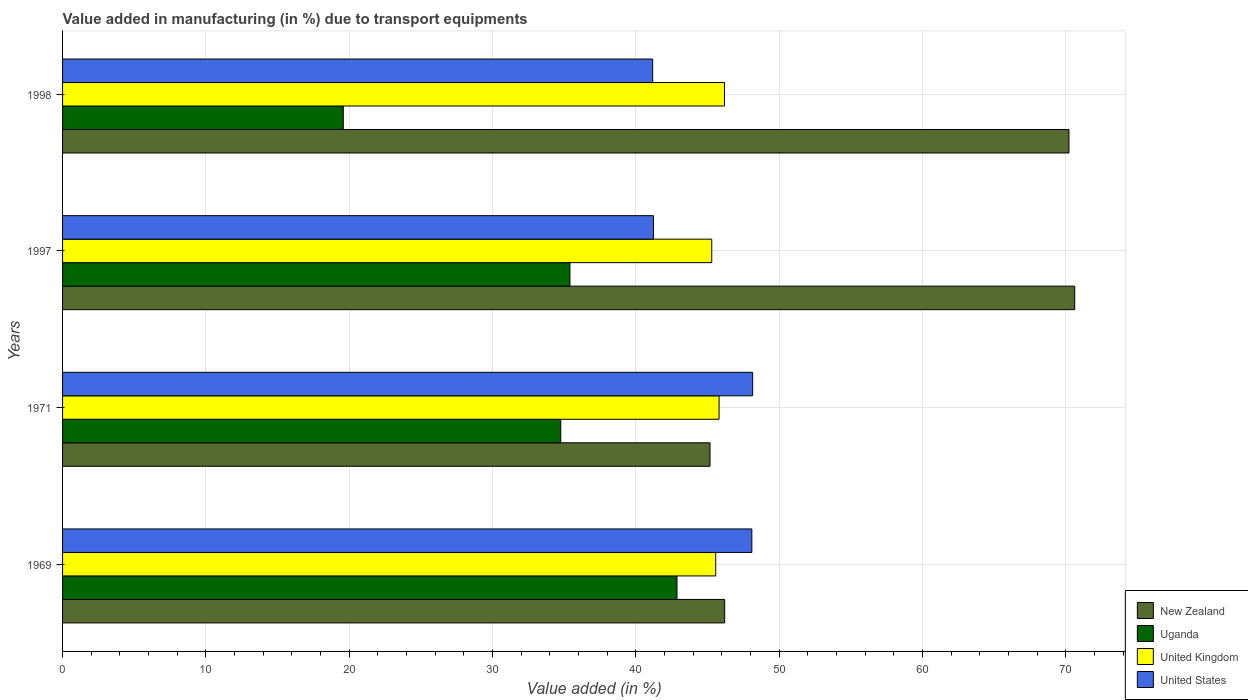How many groups of bars are there?
Make the answer very short. 4. Are the number of bars on each tick of the Y-axis equal?
Offer a terse response. Yes. How many bars are there on the 4th tick from the bottom?
Ensure brevity in your answer.  4. What is the label of the 2nd group of bars from the top?
Your response must be concise. 1997. In how many cases, is the number of bars for a given year not equal to the number of legend labels?
Keep it short and to the point. 0. What is the percentage of value added in manufacturing due to transport equipments in United Kingdom in 1969?
Keep it short and to the point. 45.58. Across all years, what is the maximum percentage of value added in manufacturing due to transport equipments in New Zealand?
Your answer should be very brief. 70.63. Across all years, what is the minimum percentage of value added in manufacturing due to transport equipments in New Zealand?
Ensure brevity in your answer.  45.18. What is the total percentage of value added in manufacturing due to transport equipments in United Kingdom in the graph?
Provide a succinct answer. 182.88. What is the difference between the percentage of value added in manufacturing due to transport equipments in Uganda in 1971 and that in 1998?
Provide a succinct answer. 15.18. What is the difference between the percentage of value added in manufacturing due to transport equipments in United Kingdom in 1969 and the percentage of value added in manufacturing due to transport equipments in United States in 1997?
Keep it short and to the point. 4.35. What is the average percentage of value added in manufacturing due to transport equipments in United Kingdom per year?
Give a very brief answer. 45.72. In the year 1997, what is the difference between the percentage of value added in manufacturing due to transport equipments in Uganda and percentage of value added in manufacturing due to transport equipments in United Kingdom?
Give a very brief answer. -9.89. In how many years, is the percentage of value added in manufacturing due to transport equipments in United States greater than 64 %?
Your response must be concise. 0. What is the ratio of the percentage of value added in manufacturing due to transport equipments in Uganda in 1969 to that in 1998?
Give a very brief answer. 2.19. Is the percentage of value added in manufacturing due to transport equipments in Uganda in 1969 less than that in 1997?
Offer a terse response. No. What is the difference between the highest and the second highest percentage of value added in manufacturing due to transport equipments in New Zealand?
Your answer should be compact. 0.4. What is the difference between the highest and the lowest percentage of value added in manufacturing due to transport equipments in New Zealand?
Make the answer very short. 25.45. In how many years, is the percentage of value added in manufacturing due to transport equipments in United Kingdom greater than the average percentage of value added in manufacturing due to transport equipments in United Kingdom taken over all years?
Your answer should be very brief. 2. Is it the case that in every year, the sum of the percentage of value added in manufacturing due to transport equipments in New Zealand and percentage of value added in manufacturing due to transport equipments in United Kingdom is greater than the sum of percentage of value added in manufacturing due to transport equipments in Uganda and percentage of value added in manufacturing due to transport equipments in United States?
Offer a terse response. No. What does the 1st bar from the top in 1971 represents?
Give a very brief answer. United States. What does the 1st bar from the bottom in 1969 represents?
Keep it short and to the point. New Zealand. How many bars are there?
Ensure brevity in your answer.  16. How many years are there in the graph?
Keep it short and to the point. 4. What is the difference between two consecutive major ticks on the X-axis?
Your answer should be very brief. 10. Are the values on the major ticks of X-axis written in scientific E-notation?
Make the answer very short. No. Does the graph contain grids?
Ensure brevity in your answer.  Yes. What is the title of the graph?
Provide a short and direct response. Value added in manufacturing (in %) due to transport equipments. Does "Hungary" appear as one of the legend labels in the graph?
Make the answer very short. No. What is the label or title of the X-axis?
Offer a very short reply. Value added (in %). What is the label or title of the Y-axis?
Your answer should be compact. Years. What is the Value added (in %) in New Zealand in 1969?
Your answer should be very brief. 46.2. What is the Value added (in %) in Uganda in 1969?
Your response must be concise. 42.87. What is the Value added (in %) of United Kingdom in 1969?
Give a very brief answer. 45.58. What is the Value added (in %) of United States in 1969?
Make the answer very short. 48.1. What is the Value added (in %) in New Zealand in 1971?
Offer a very short reply. 45.18. What is the Value added (in %) of Uganda in 1971?
Offer a terse response. 34.76. What is the Value added (in %) in United Kingdom in 1971?
Keep it short and to the point. 45.81. What is the Value added (in %) in United States in 1971?
Ensure brevity in your answer.  48.15. What is the Value added (in %) in New Zealand in 1997?
Keep it short and to the point. 70.63. What is the Value added (in %) of Uganda in 1997?
Make the answer very short. 35.41. What is the Value added (in %) in United Kingdom in 1997?
Give a very brief answer. 45.3. What is the Value added (in %) in United States in 1997?
Your answer should be very brief. 41.23. What is the Value added (in %) in New Zealand in 1998?
Give a very brief answer. 70.23. What is the Value added (in %) in Uganda in 1998?
Your response must be concise. 19.59. What is the Value added (in %) in United Kingdom in 1998?
Your answer should be compact. 46.19. What is the Value added (in %) in United States in 1998?
Offer a terse response. 41.18. Across all years, what is the maximum Value added (in %) of New Zealand?
Ensure brevity in your answer.  70.63. Across all years, what is the maximum Value added (in %) in Uganda?
Provide a short and direct response. 42.87. Across all years, what is the maximum Value added (in %) of United Kingdom?
Give a very brief answer. 46.19. Across all years, what is the maximum Value added (in %) of United States?
Your answer should be very brief. 48.15. Across all years, what is the minimum Value added (in %) of New Zealand?
Keep it short and to the point. 45.18. Across all years, what is the minimum Value added (in %) in Uganda?
Keep it short and to the point. 19.59. Across all years, what is the minimum Value added (in %) of United Kingdom?
Offer a very short reply. 45.3. Across all years, what is the minimum Value added (in %) in United States?
Your response must be concise. 41.18. What is the total Value added (in %) of New Zealand in the graph?
Your answer should be very brief. 232.24. What is the total Value added (in %) in Uganda in the graph?
Your answer should be compact. 132.63. What is the total Value added (in %) of United Kingdom in the graph?
Your answer should be compact. 182.88. What is the total Value added (in %) in United States in the graph?
Offer a very short reply. 178.66. What is the difference between the Value added (in %) in New Zealand in 1969 and that in 1971?
Ensure brevity in your answer.  1.02. What is the difference between the Value added (in %) of Uganda in 1969 and that in 1971?
Provide a succinct answer. 8.11. What is the difference between the Value added (in %) in United Kingdom in 1969 and that in 1971?
Your answer should be compact. -0.24. What is the difference between the Value added (in %) in United States in 1969 and that in 1971?
Your response must be concise. -0.05. What is the difference between the Value added (in %) in New Zealand in 1969 and that in 1997?
Your answer should be very brief. -24.43. What is the difference between the Value added (in %) of Uganda in 1969 and that in 1997?
Provide a succinct answer. 7.47. What is the difference between the Value added (in %) in United Kingdom in 1969 and that in 1997?
Keep it short and to the point. 0.28. What is the difference between the Value added (in %) in United States in 1969 and that in 1997?
Provide a succinct answer. 6.87. What is the difference between the Value added (in %) in New Zealand in 1969 and that in 1998?
Offer a terse response. -24.03. What is the difference between the Value added (in %) of Uganda in 1969 and that in 1998?
Your answer should be compact. 23.29. What is the difference between the Value added (in %) of United Kingdom in 1969 and that in 1998?
Offer a terse response. -0.61. What is the difference between the Value added (in %) of United States in 1969 and that in 1998?
Keep it short and to the point. 6.92. What is the difference between the Value added (in %) of New Zealand in 1971 and that in 1997?
Offer a terse response. -25.45. What is the difference between the Value added (in %) in Uganda in 1971 and that in 1997?
Ensure brevity in your answer.  -0.64. What is the difference between the Value added (in %) of United Kingdom in 1971 and that in 1997?
Your answer should be compact. 0.51. What is the difference between the Value added (in %) in United States in 1971 and that in 1997?
Offer a very short reply. 6.92. What is the difference between the Value added (in %) of New Zealand in 1971 and that in 1998?
Offer a very short reply. -25.05. What is the difference between the Value added (in %) in Uganda in 1971 and that in 1998?
Your response must be concise. 15.18. What is the difference between the Value added (in %) of United Kingdom in 1971 and that in 1998?
Provide a succinct answer. -0.38. What is the difference between the Value added (in %) of United States in 1971 and that in 1998?
Keep it short and to the point. 6.98. What is the difference between the Value added (in %) in New Zealand in 1997 and that in 1998?
Your answer should be very brief. 0.4. What is the difference between the Value added (in %) of Uganda in 1997 and that in 1998?
Your answer should be compact. 15.82. What is the difference between the Value added (in %) in United Kingdom in 1997 and that in 1998?
Give a very brief answer. -0.89. What is the difference between the Value added (in %) in United States in 1997 and that in 1998?
Make the answer very short. 0.05. What is the difference between the Value added (in %) in New Zealand in 1969 and the Value added (in %) in Uganda in 1971?
Provide a short and direct response. 11.44. What is the difference between the Value added (in %) in New Zealand in 1969 and the Value added (in %) in United Kingdom in 1971?
Your response must be concise. 0.39. What is the difference between the Value added (in %) of New Zealand in 1969 and the Value added (in %) of United States in 1971?
Your answer should be compact. -1.95. What is the difference between the Value added (in %) in Uganda in 1969 and the Value added (in %) in United Kingdom in 1971?
Your answer should be very brief. -2.94. What is the difference between the Value added (in %) of Uganda in 1969 and the Value added (in %) of United States in 1971?
Your answer should be compact. -5.28. What is the difference between the Value added (in %) of United Kingdom in 1969 and the Value added (in %) of United States in 1971?
Provide a succinct answer. -2.58. What is the difference between the Value added (in %) in New Zealand in 1969 and the Value added (in %) in Uganda in 1997?
Keep it short and to the point. 10.8. What is the difference between the Value added (in %) in New Zealand in 1969 and the Value added (in %) in United Kingdom in 1997?
Provide a succinct answer. 0.9. What is the difference between the Value added (in %) in New Zealand in 1969 and the Value added (in %) in United States in 1997?
Your response must be concise. 4.97. What is the difference between the Value added (in %) in Uganda in 1969 and the Value added (in %) in United Kingdom in 1997?
Offer a very short reply. -2.43. What is the difference between the Value added (in %) of Uganda in 1969 and the Value added (in %) of United States in 1997?
Your answer should be compact. 1.64. What is the difference between the Value added (in %) of United Kingdom in 1969 and the Value added (in %) of United States in 1997?
Provide a succinct answer. 4.35. What is the difference between the Value added (in %) in New Zealand in 1969 and the Value added (in %) in Uganda in 1998?
Offer a very short reply. 26.61. What is the difference between the Value added (in %) in New Zealand in 1969 and the Value added (in %) in United Kingdom in 1998?
Offer a very short reply. 0.01. What is the difference between the Value added (in %) of New Zealand in 1969 and the Value added (in %) of United States in 1998?
Make the answer very short. 5.02. What is the difference between the Value added (in %) in Uganda in 1969 and the Value added (in %) in United Kingdom in 1998?
Ensure brevity in your answer.  -3.32. What is the difference between the Value added (in %) in Uganda in 1969 and the Value added (in %) in United States in 1998?
Provide a succinct answer. 1.7. What is the difference between the Value added (in %) in United Kingdom in 1969 and the Value added (in %) in United States in 1998?
Give a very brief answer. 4.4. What is the difference between the Value added (in %) of New Zealand in 1971 and the Value added (in %) of Uganda in 1997?
Ensure brevity in your answer.  9.77. What is the difference between the Value added (in %) of New Zealand in 1971 and the Value added (in %) of United Kingdom in 1997?
Make the answer very short. -0.12. What is the difference between the Value added (in %) of New Zealand in 1971 and the Value added (in %) of United States in 1997?
Provide a succinct answer. 3.95. What is the difference between the Value added (in %) of Uganda in 1971 and the Value added (in %) of United Kingdom in 1997?
Your answer should be compact. -10.54. What is the difference between the Value added (in %) in Uganda in 1971 and the Value added (in %) in United States in 1997?
Provide a succinct answer. -6.47. What is the difference between the Value added (in %) in United Kingdom in 1971 and the Value added (in %) in United States in 1997?
Provide a succinct answer. 4.58. What is the difference between the Value added (in %) in New Zealand in 1971 and the Value added (in %) in Uganda in 1998?
Give a very brief answer. 25.59. What is the difference between the Value added (in %) in New Zealand in 1971 and the Value added (in %) in United Kingdom in 1998?
Ensure brevity in your answer.  -1.01. What is the difference between the Value added (in %) in New Zealand in 1971 and the Value added (in %) in United States in 1998?
Your answer should be compact. 4. What is the difference between the Value added (in %) of Uganda in 1971 and the Value added (in %) of United Kingdom in 1998?
Give a very brief answer. -11.43. What is the difference between the Value added (in %) of Uganda in 1971 and the Value added (in %) of United States in 1998?
Keep it short and to the point. -6.41. What is the difference between the Value added (in %) of United Kingdom in 1971 and the Value added (in %) of United States in 1998?
Your answer should be compact. 4.63. What is the difference between the Value added (in %) of New Zealand in 1997 and the Value added (in %) of Uganda in 1998?
Give a very brief answer. 51.04. What is the difference between the Value added (in %) in New Zealand in 1997 and the Value added (in %) in United Kingdom in 1998?
Keep it short and to the point. 24.44. What is the difference between the Value added (in %) in New Zealand in 1997 and the Value added (in %) in United States in 1998?
Your answer should be very brief. 29.45. What is the difference between the Value added (in %) of Uganda in 1997 and the Value added (in %) of United Kingdom in 1998?
Ensure brevity in your answer.  -10.78. What is the difference between the Value added (in %) of Uganda in 1997 and the Value added (in %) of United States in 1998?
Your response must be concise. -5.77. What is the difference between the Value added (in %) of United Kingdom in 1997 and the Value added (in %) of United States in 1998?
Offer a very short reply. 4.12. What is the average Value added (in %) in New Zealand per year?
Give a very brief answer. 58.06. What is the average Value added (in %) of Uganda per year?
Give a very brief answer. 33.16. What is the average Value added (in %) in United Kingdom per year?
Keep it short and to the point. 45.72. What is the average Value added (in %) of United States per year?
Ensure brevity in your answer.  44.67. In the year 1969, what is the difference between the Value added (in %) of New Zealand and Value added (in %) of Uganda?
Provide a succinct answer. 3.33. In the year 1969, what is the difference between the Value added (in %) in New Zealand and Value added (in %) in United Kingdom?
Make the answer very short. 0.62. In the year 1969, what is the difference between the Value added (in %) of New Zealand and Value added (in %) of United States?
Keep it short and to the point. -1.9. In the year 1969, what is the difference between the Value added (in %) in Uganda and Value added (in %) in United Kingdom?
Keep it short and to the point. -2.7. In the year 1969, what is the difference between the Value added (in %) in Uganda and Value added (in %) in United States?
Give a very brief answer. -5.22. In the year 1969, what is the difference between the Value added (in %) in United Kingdom and Value added (in %) in United States?
Offer a terse response. -2.52. In the year 1971, what is the difference between the Value added (in %) in New Zealand and Value added (in %) in Uganda?
Ensure brevity in your answer.  10.41. In the year 1971, what is the difference between the Value added (in %) of New Zealand and Value added (in %) of United Kingdom?
Make the answer very short. -0.63. In the year 1971, what is the difference between the Value added (in %) in New Zealand and Value added (in %) in United States?
Your answer should be compact. -2.97. In the year 1971, what is the difference between the Value added (in %) in Uganda and Value added (in %) in United Kingdom?
Give a very brief answer. -11.05. In the year 1971, what is the difference between the Value added (in %) in Uganda and Value added (in %) in United States?
Your response must be concise. -13.39. In the year 1971, what is the difference between the Value added (in %) of United Kingdom and Value added (in %) of United States?
Give a very brief answer. -2.34. In the year 1997, what is the difference between the Value added (in %) in New Zealand and Value added (in %) in Uganda?
Your answer should be very brief. 35.22. In the year 1997, what is the difference between the Value added (in %) of New Zealand and Value added (in %) of United Kingdom?
Provide a succinct answer. 25.33. In the year 1997, what is the difference between the Value added (in %) in New Zealand and Value added (in %) in United States?
Your answer should be very brief. 29.4. In the year 1997, what is the difference between the Value added (in %) in Uganda and Value added (in %) in United Kingdom?
Give a very brief answer. -9.89. In the year 1997, what is the difference between the Value added (in %) in Uganda and Value added (in %) in United States?
Your response must be concise. -5.83. In the year 1997, what is the difference between the Value added (in %) in United Kingdom and Value added (in %) in United States?
Ensure brevity in your answer.  4.07. In the year 1998, what is the difference between the Value added (in %) in New Zealand and Value added (in %) in Uganda?
Keep it short and to the point. 50.64. In the year 1998, what is the difference between the Value added (in %) of New Zealand and Value added (in %) of United Kingdom?
Offer a terse response. 24.04. In the year 1998, what is the difference between the Value added (in %) of New Zealand and Value added (in %) of United States?
Make the answer very short. 29.05. In the year 1998, what is the difference between the Value added (in %) in Uganda and Value added (in %) in United Kingdom?
Give a very brief answer. -26.6. In the year 1998, what is the difference between the Value added (in %) in Uganda and Value added (in %) in United States?
Your response must be concise. -21.59. In the year 1998, what is the difference between the Value added (in %) in United Kingdom and Value added (in %) in United States?
Provide a succinct answer. 5.01. What is the ratio of the Value added (in %) of New Zealand in 1969 to that in 1971?
Give a very brief answer. 1.02. What is the ratio of the Value added (in %) in Uganda in 1969 to that in 1971?
Ensure brevity in your answer.  1.23. What is the ratio of the Value added (in %) of United Kingdom in 1969 to that in 1971?
Offer a terse response. 0.99. What is the ratio of the Value added (in %) in United States in 1969 to that in 1971?
Give a very brief answer. 1. What is the ratio of the Value added (in %) in New Zealand in 1969 to that in 1997?
Provide a succinct answer. 0.65. What is the ratio of the Value added (in %) of Uganda in 1969 to that in 1997?
Keep it short and to the point. 1.21. What is the ratio of the Value added (in %) in United Kingdom in 1969 to that in 1997?
Provide a short and direct response. 1.01. What is the ratio of the Value added (in %) of United States in 1969 to that in 1997?
Offer a terse response. 1.17. What is the ratio of the Value added (in %) of New Zealand in 1969 to that in 1998?
Provide a short and direct response. 0.66. What is the ratio of the Value added (in %) in Uganda in 1969 to that in 1998?
Your answer should be very brief. 2.19. What is the ratio of the Value added (in %) of United Kingdom in 1969 to that in 1998?
Make the answer very short. 0.99. What is the ratio of the Value added (in %) in United States in 1969 to that in 1998?
Give a very brief answer. 1.17. What is the ratio of the Value added (in %) of New Zealand in 1971 to that in 1997?
Your answer should be very brief. 0.64. What is the ratio of the Value added (in %) in Uganda in 1971 to that in 1997?
Keep it short and to the point. 0.98. What is the ratio of the Value added (in %) in United Kingdom in 1971 to that in 1997?
Make the answer very short. 1.01. What is the ratio of the Value added (in %) of United States in 1971 to that in 1997?
Offer a terse response. 1.17. What is the ratio of the Value added (in %) in New Zealand in 1971 to that in 1998?
Your answer should be very brief. 0.64. What is the ratio of the Value added (in %) in Uganda in 1971 to that in 1998?
Ensure brevity in your answer.  1.77. What is the ratio of the Value added (in %) in United Kingdom in 1971 to that in 1998?
Offer a very short reply. 0.99. What is the ratio of the Value added (in %) of United States in 1971 to that in 1998?
Make the answer very short. 1.17. What is the ratio of the Value added (in %) in Uganda in 1997 to that in 1998?
Make the answer very short. 1.81. What is the ratio of the Value added (in %) of United Kingdom in 1997 to that in 1998?
Keep it short and to the point. 0.98. What is the ratio of the Value added (in %) of United States in 1997 to that in 1998?
Your answer should be compact. 1. What is the difference between the highest and the second highest Value added (in %) in New Zealand?
Your response must be concise. 0.4. What is the difference between the highest and the second highest Value added (in %) in Uganda?
Ensure brevity in your answer.  7.47. What is the difference between the highest and the second highest Value added (in %) in United Kingdom?
Provide a succinct answer. 0.38. What is the difference between the highest and the second highest Value added (in %) of United States?
Give a very brief answer. 0.05. What is the difference between the highest and the lowest Value added (in %) of New Zealand?
Keep it short and to the point. 25.45. What is the difference between the highest and the lowest Value added (in %) of Uganda?
Offer a terse response. 23.29. What is the difference between the highest and the lowest Value added (in %) of United Kingdom?
Make the answer very short. 0.89. What is the difference between the highest and the lowest Value added (in %) of United States?
Offer a terse response. 6.98. 